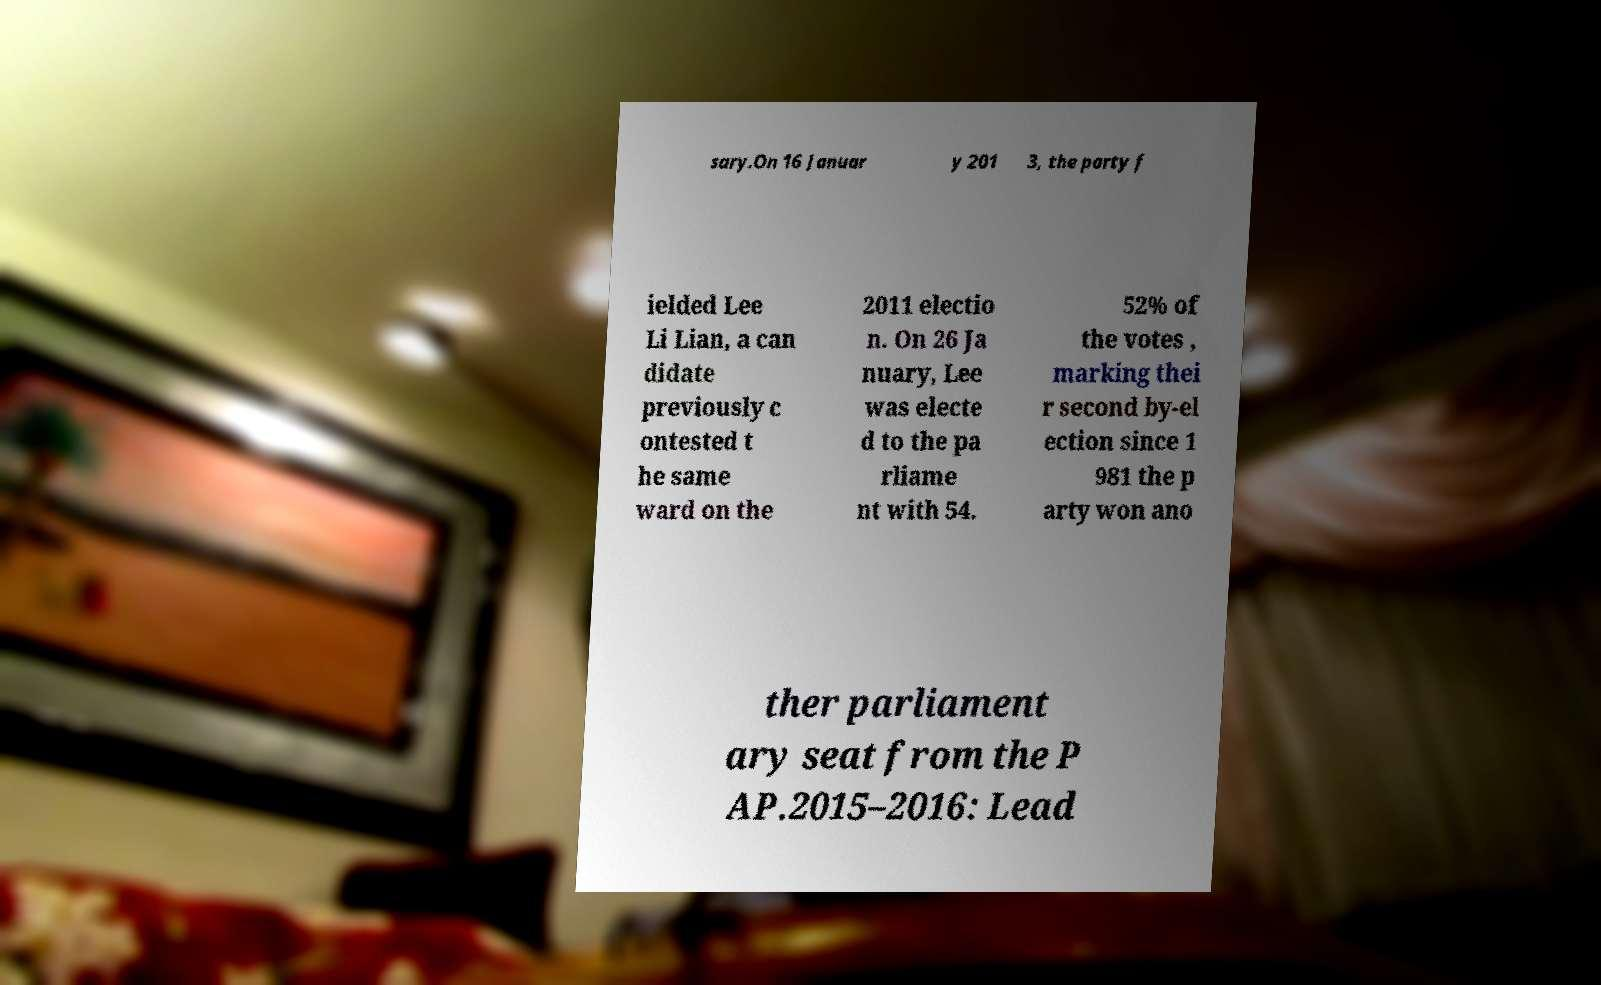Can you accurately transcribe the text from the provided image for me? sary.On 16 Januar y 201 3, the party f ielded Lee Li Lian, a can didate previously c ontested t he same ward on the 2011 electio n. On 26 Ja nuary, Lee was electe d to the pa rliame nt with 54. 52% of the votes , marking thei r second by-el ection since 1 981 the p arty won ano ther parliament ary seat from the P AP.2015–2016: Lead 